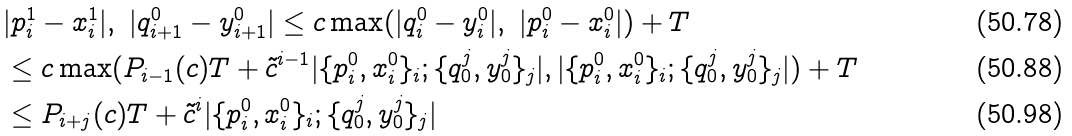Convert formula to latex. <formula><loc_0><loc_0><loc_500><loc_500>& | p _ { i } ^ { 1 } - x _ { i } ^ { 1 } | , \ | q _ { i + 1 } ^ { 0 } - y _ { i + 1 } ^ { 0 } | \leq c \max ( | q _ { i } ^ { 0 } - y _ { i } ^ { 0 } | , \ | p _ { i } ^ { 0 } - x _ { i } ^ { 0 } | ) + T \\ & \leq c \max ( P _ { i - 1 } ( c ) T + \tilde { c } ^ { i - 1 } | \{ p _ { i } ^ { 0 } , x _ { i } ^ { 0 } \} _ { i } ; \{ q ^ { j } _ { 0 } , y ^ { j } _ { 0 } \} _ { j } | , | \{ p _ { i } ^ { 0 } , x _ { i } ^ { 0 } \} _ { i } ; \{ q ^ { j } _ { 0 } , y ^ { j } _ { 0 } \} _ { j } | ) + T \\ & \leq P _ { i + j } ( c ) T + \tilde { c } ^ { i } | \{ p _ { i } ^ { 0 } , x _ { i } ^ { 0 } \} _ { i } ; \{ q ^ { j } _ { 0 } , y ^ { j } _ { 0 } \} _ { j } |</formula> 